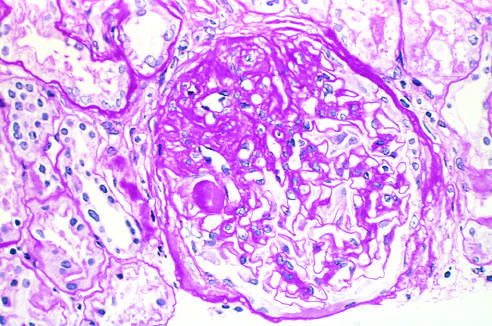re the focal and segmental glomerulosclerosis (periodic acid-schiff stain) seen as a collection of scarred, obliterate capillaries and accumula-tions of matrix material in part of the affected glomerulus?
Answer the question using a single word or phrase. Yes 